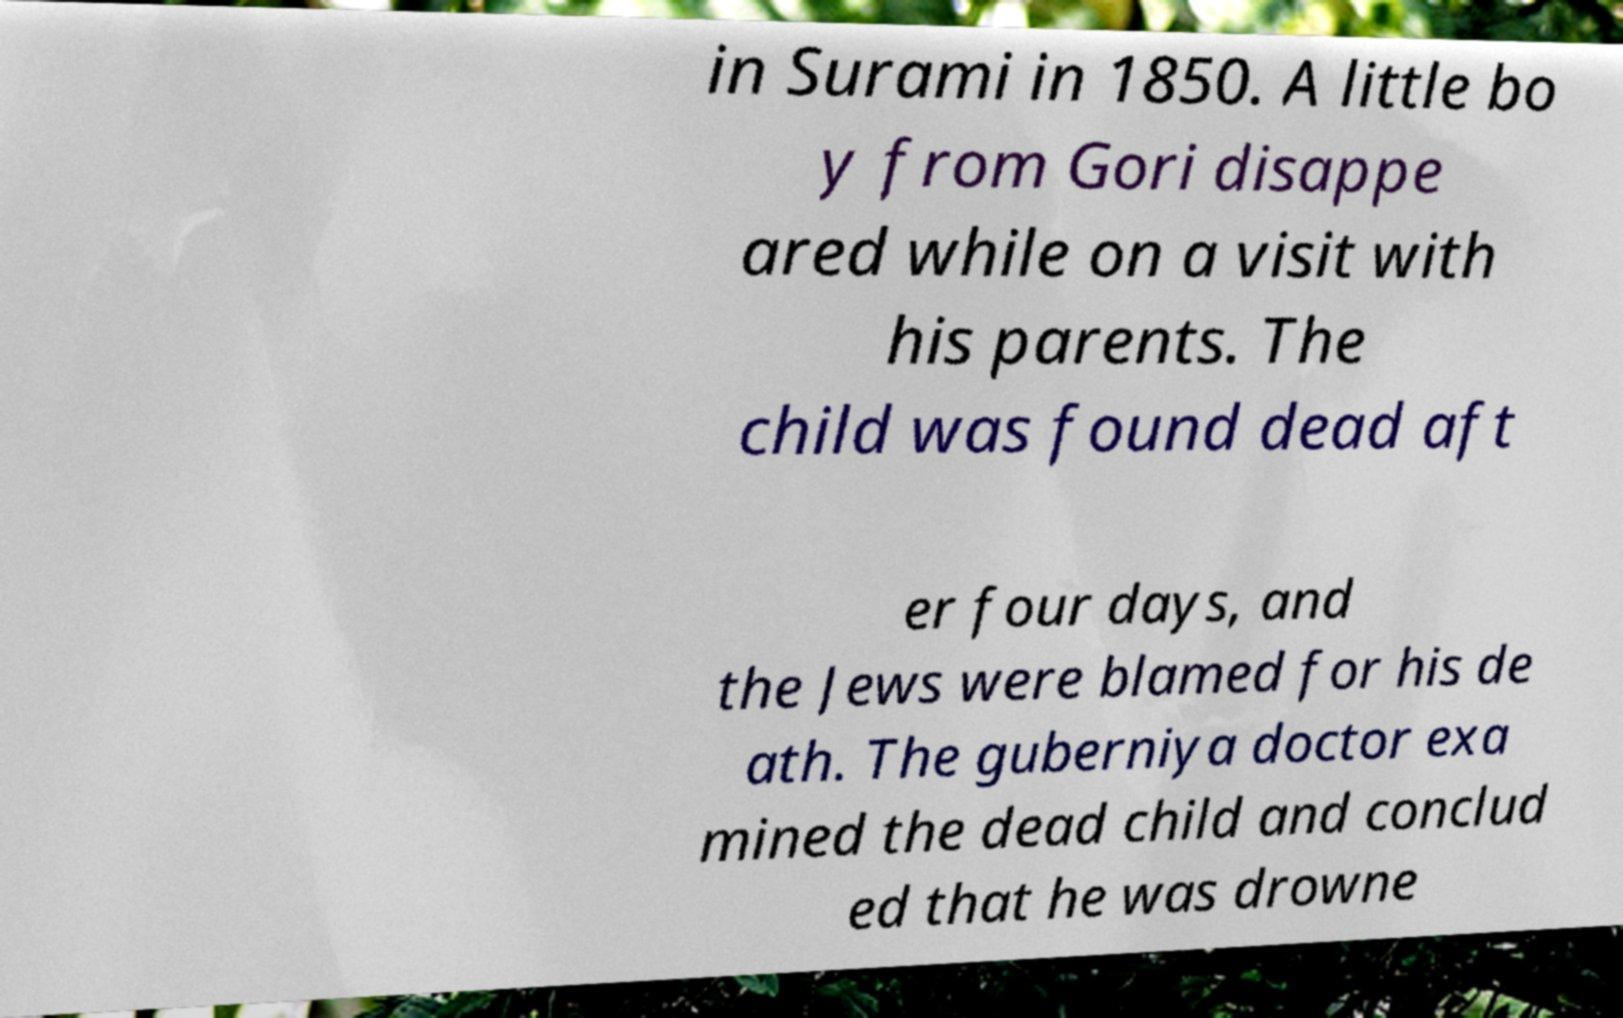Please read and relay the text visible in this image. What does it say? in Surami in 1850. A little bo y from Gori disappe ared while on a visit with his parents. The child was found dead aft er four days, and the Jews were blamed for his de ath. The guberniya doctor exa mined the dead child and conclud ed that he was drowne 